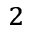Convert formula to latex. <formula><loc_0><loc_0><loc_500><loc_500>^ { 2 }</formula> 